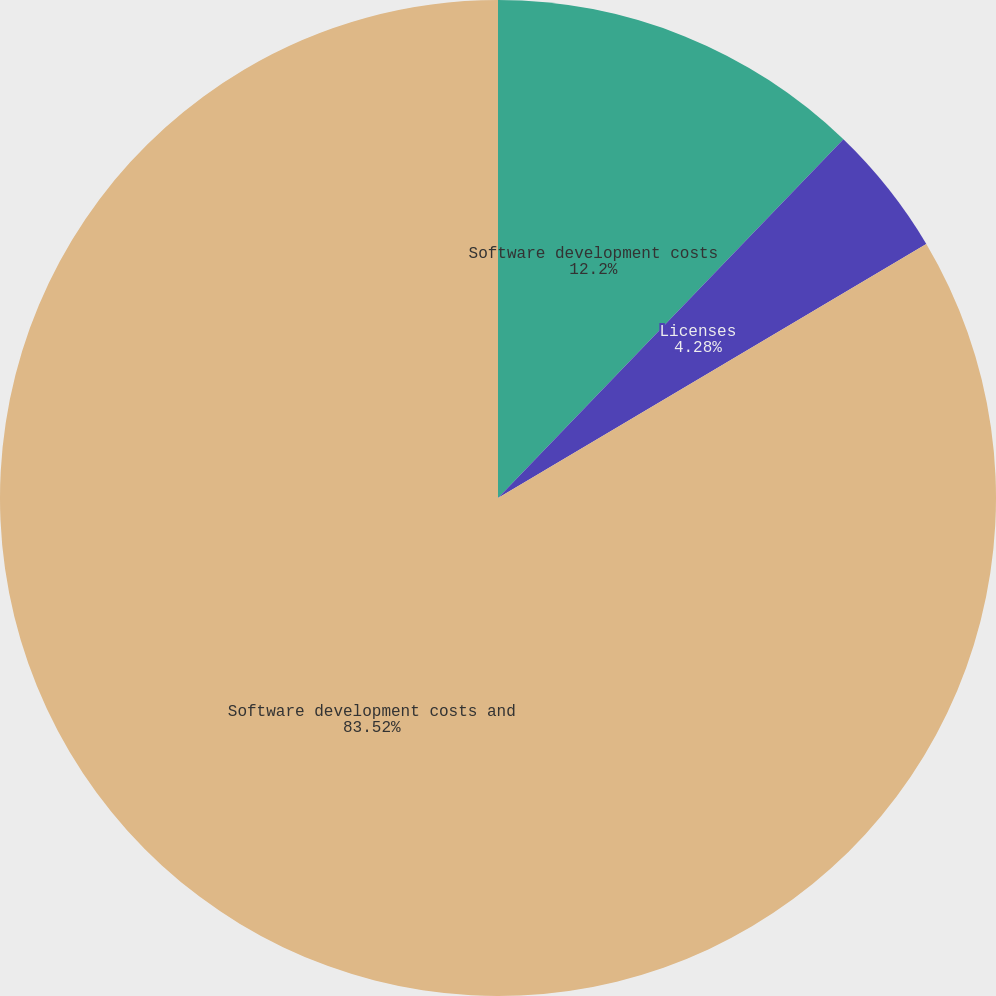Convert chart to OTSL. <chart><loc_0><loc_0><loc_500><loc_500><pie_chart><fcel>Software development costs<fcel>Licenses<fcel>Software development costs and<nl><fcel>12.2%<fcel>4.28%<fcel>83.52%<nl></chart> 